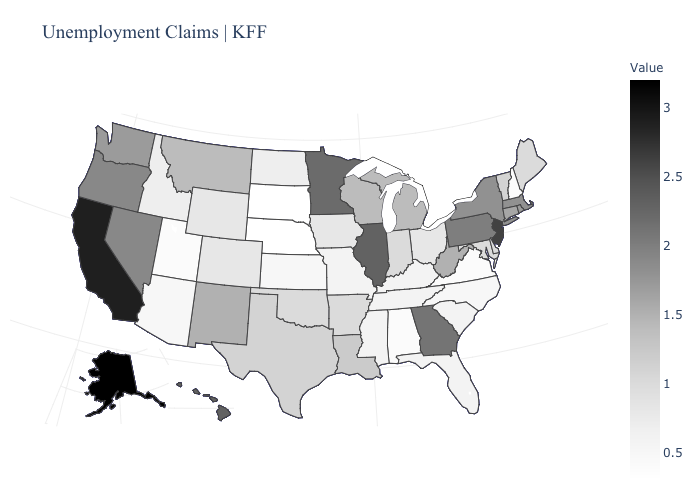Does Indiana have the lowest value in the USA?
Short answer required. No. Is the legend a continuous bar?
Keep it brief. Yes. Does Illinois have a lower value than California?
Be succinct. Yes. Among the states that border Indiana , does Kentucky have the lowest value?
Answer briefly. Yes. Which states have the lowest value in the USA?
Give a very brief answer. Nebraska, South Dakota. Which states hav the highest value in the Northeast?
Write a very short answer. New Jersey. 